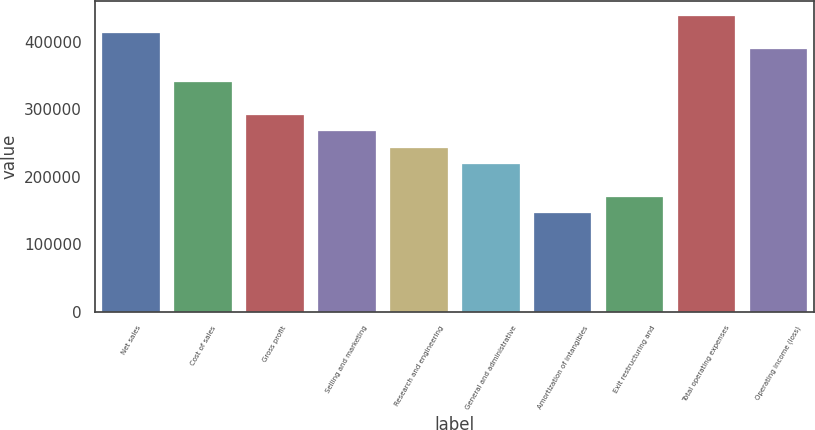<chart> <loc_0><loc_0><loc_500><loc_500><bar_chart><fcel>Net sales<fcel>Cost of sales<fcel>Gross profit<fcel>Selling and marketing<fcel>Research and engineering<fcel>General and administrative<fcel>Amortization of intangibles<fcel>Exit restructuring and<fcel>Total operating expenses<fcel>Operating income (loss)<nl><fcel>413503<fcel>340532<fcel>291885<fcel>267562<fcel>243238<fcel>218914<fcel>145944<fcel>170267<fcel>437827<fcel>389180<nl></chart> 